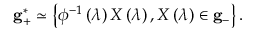Convert formula to latex. <formula><loc_0><loc_0><loc_500><loc_500>{ g } _ { + } ^ { * } \simeq \left \{ \phi ^ { - 1 } \left ( \lambda \right ) X \left ( \lambda \right ) , X \left ( \lambda \right ) \in { g } _ { - } \right \} .</formula> 